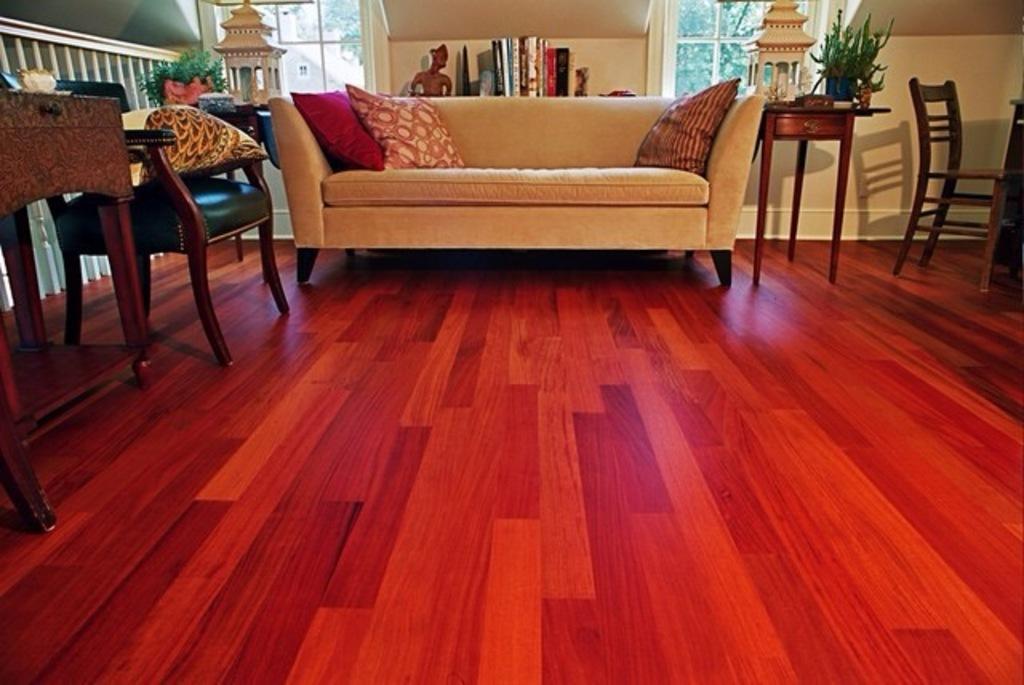In one or two sentences, can you explain what this image depicts? In this picture we can see one roach and some pillows on the couch. In the left side we can see one chair and one table and some decorative items in the right side we can see one chair in some decorative items back side there is a shelf and some books are being places and one toy. 